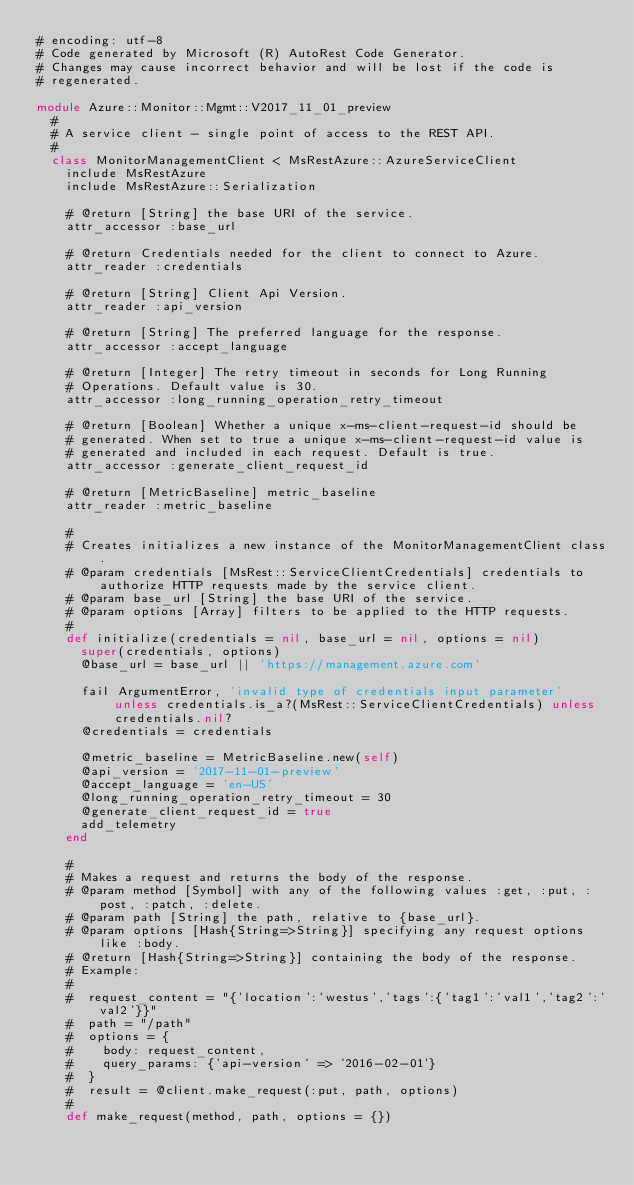Convert code to text. <code><loc_0><loc_0><loc_500><loc_500><_Ruby_># encoding: utf-8
# Code generated by Microsoft (R) AutoRest Code Generator.
# Changes may cause incorrect behavior and will be lost if the code is
# regenerated.

module Azure::Monitor::Mgmt::V2017_11_01_preview
  #
  # A service client - single point of access to the REST API.
  #
  class MonitorManagementClient < MsRestAzure::AzureServiceClient
    include MsRestAzure
    include MsRestAzure::Serialization

    # @return [String] the base URI of the service.
    attr_accessor :base_url

    # @return Credentials needed for the client to connect to Azure.
    attr_reader :credentials

    # @return [String] Client Api Version.
    attr_reader :api_version

    # @return [String] The preferred language for the response.
    attr_accessor :accept_language

    # @return [Integer] The retry timeout in seconds for Long Running
    # Operations. Default value is 30.
    attr_accessor :long_running_operation_retry_timeout

    # @return [Boolean] Whether a unique x-ms-client-request-id should be
    # generated. When set to true a unique x-ms-client-request-id value is
    # generated and included in each request. Default is true.
    attr_accessor :generate_client_request_id

    # @return [MetricBaseline] metric_baseline
    attr_reader :metric_baseline

    #
    # Creates initializes a new instance of the MonitorManagementClient class.
    # @param credentials [MsRest::ServiceClientCredentials] credentials to authorize HTTP requests made by the service client.
    # @param base_url [String] the base URI of the service.
    # @param options [Array] filters to be applied to the HTTP requests.
    #
    def initialize(credentials = nil, base_url = nil, options = nil)
      super(credentials, options)
      @base_url = base_url || 'https://management.azure.com'

      fail ArgumentError, 'invalid type of credentials input parameter' unless credentials.is_a?(MsRest::ServiceClientCredentials) unless credentials.nil?
      @credentials = credentials

      @metric_baseline = MetricBaseline.new(self)
      @api_version = '2017-11-01-preview'
      @accept_language = 'en-US'
      @long_running_operation_retry_timeout = 30
      @generate_client_request_id = true
      add_telemetry
    end

    #
    # Makes a request and returns the body of the response.
    # @param method [Symbol] with any of the following values :get, :put, :post, :patch, :delete.
    # @param path [String] the path, relative to {base_url}.
    # @param options [Hash{String=>String}] specifying any request options like :body.
    # @return [Hash{String=>String}] containing the body of the response.
    # Example:
    #
    #  request_content = "{'location':'westus','tags':{'tag1':'val1','tag2':'val2'}}"
    #  path = "/path"
    #  options = {
    #    body: request_content,
    #    query_params: {'api-version' => '2016-02-01'}
    #  }
    #  result = @client.make_request(:put, path, options)
    #
    def make_request(method, path, options = {})</code> 